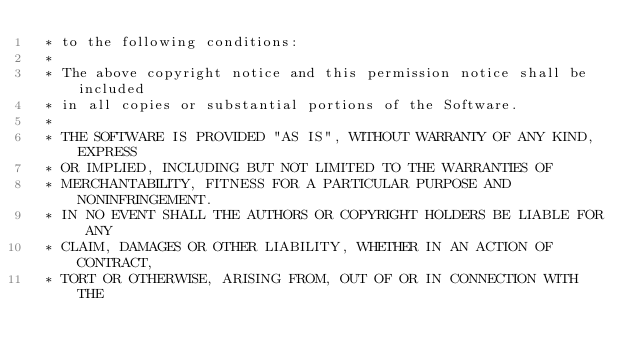Convert code to text. <code><loc_0><loc_0><loc_500><loc_500><_C_> * to the following conditions:
 *
 * The above copyright notice and this permission notice shall be included
 * in all copies or substantial portions of the Software.
 *
 * THE SOFTWARE IS PROVIDED "AS IS", WITHOUT WARRANTY OF ANY KIND, EXPRESS
 * OR IMPLIED, INCLUDING BUT NOT LIMITED TO THE WARRANTIES OF
 * MERCHANTABILITY, FITNESS FOR A PARTICULAR PURPOSE AND NONINFRINGEMENT.
 * IN NO EVENT SHALL THE AUTHORS OR COPYRIGHT HOLDERS BE LIABLE FOR ANY
 * CLAIM, DAMAGES OR OTHER LIABILITY, WHETHER IN AN ACTION OF CONTRACT,
 * TORT OR OTHERWISE, ARISING FROM, OUT OF OR IN CONNECTION WITH THE</code> 